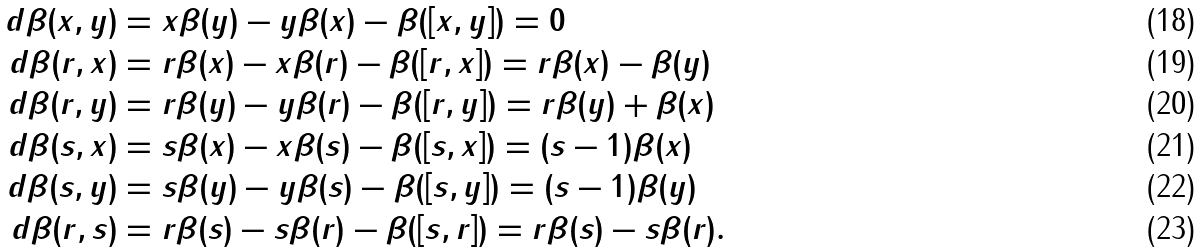<formula> <loc_0><loc_0><loc_500><loc_500>d \beta ( x , y ) & = x \beta ( y ) - y \beta ( x ) - \beta ( [ x , y ] ) = 0 \\ d \beta ( r , x ) & = r \beta ( x ) - x \beta ( r ) - \beta ( [ r , x ] ) = r \beta ( x ) - \beta ( y ) \\ d \beta ( r , y ) & = r \beta ( y ) - y \beta ( r ) - \beta ( [ r , y ] ) = r \beta ( y ) + \beta ( x ) \\ d \beta ( s , x ) & = s \beta ( x ) - x \beta ( s ) - \beta ( [ s , x ] ) = ( s - 1 ) \beta ( x ) \\ d \beta ( s , y ) & = s \beta ( y ) - y \beta ( s ) - \beta ( [ s , y ] ) = ( s - 1 ) \beta ( y ) \\ d \beta ( r , s ) & = r \beta ( s ) - s \beta ( r ) - \beta ( [ s , r ] ) = r \beta ( s ) - s \beta ( r ) .</formula> 